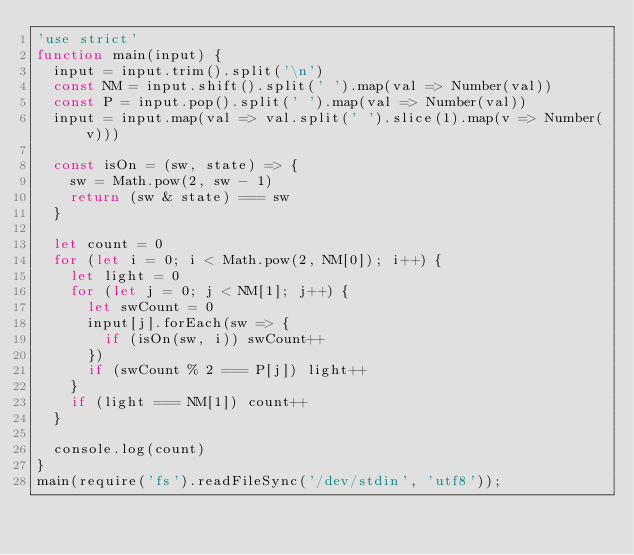Convert code to text. <code><loc_0><loc_0><loc_500><loc_500><_JavaScript_>'use strict'
function main(input) {
  input = input.trim().split('\n')
  const NM = input.shift().split(' ').map(val => Number(val))
  const P = input.pop().split(' ').map(val => Number(val))
  input = input.map(val => val.split(' ').slice(1).map(v => Number(v)))

  const isOn = (sw, state) => {
    sw = Math.pow(2, sw - 1)
    return (sw & state) === sw
  }
  
  let count = 0
  for (let i = 0; i < Math.pow(2, NM[0]); i++) {
    let light = 0
    for (let j = 0; j < NM[1]; j++) {
      let swCount = 0
      input[j].forEach(sw => {
        if (isOn(sw, i)) swCount++
      })
      if (swCount % 2 === P[j]) light++
    }
    if (light === NM[1]) count++
  }

  console.log(count)
}
main(require('fs').readFileSync('/dev/stdin', 'utf8'));
</code> 